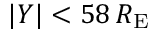Convert formula to latex. <formula><loc_0><loc_0><loc_500><loc_500>| Y | < 5 8 \, R _ { E }</formula> 